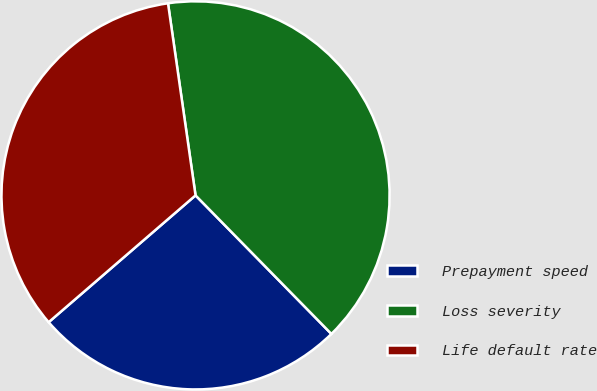Convert chart. <chart><loc_0><loc_0><loc_500><loc_500><pie_chart><fcel>Prepayment speed<fcel>Loss severity<fcel>Life default rate<nl><fcel>26.01%<fcel>39.92%<fcel>34.07%<nl></chart> 